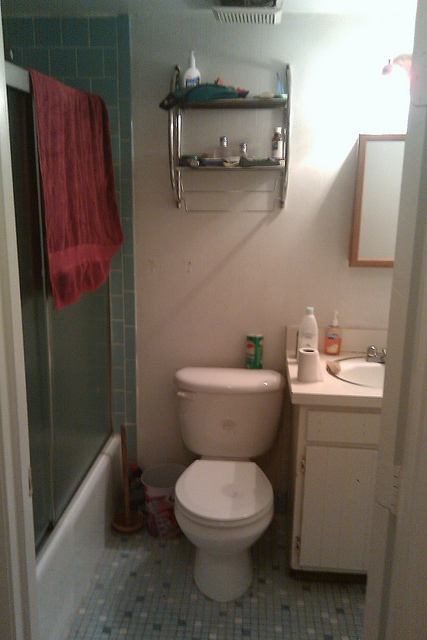Describe a realistic morning routine in this bathroom. A typical morning routine in this bathroom might start with a quick shower, using the products stored on the shelves above. After drying off with the towel hanging beside the shower, one might brush their teeth with the toothpaste kept in the container on the toilet tank while looking in the mirror above the sink. They might wash their hands and face with the soap dispenser on the counter, perhaps followed by a quick shave or hair styling. Finally, checking their outfit or appearance one last time in the mirror before heading out for the day. 